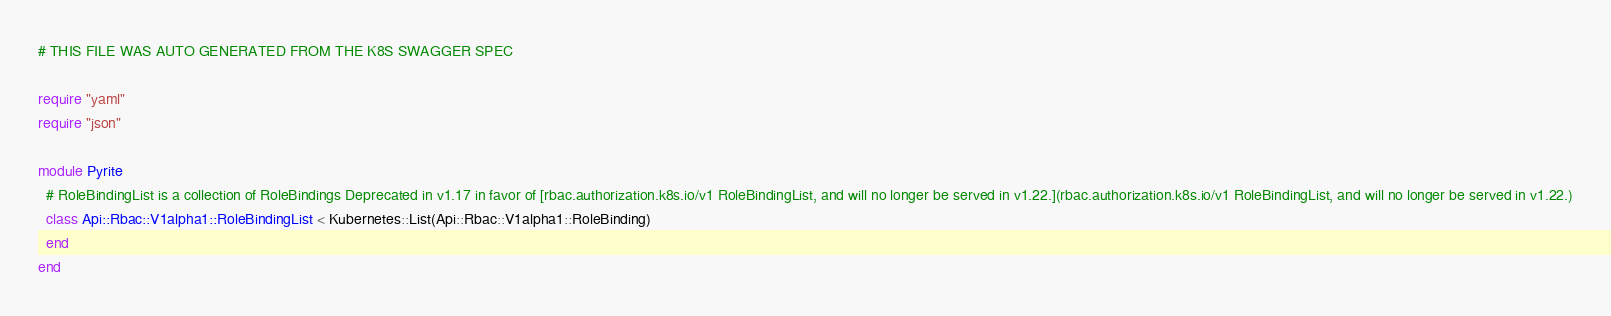<code> <loc_0><loc_0><loc_500><loc_500><_Crystal_># THIS FILE WAS AUTO GENERATED FROM THE K8S SWAGGER SPEC

require "yaml"
require "json"

module Pyrite
  # RoleBindingList is a collection of RoleBindings Deprecated in v1.17 in favor of [rbac.authorization.k8s.io/v1 RoleBindingList, and will no longer be served in v1.22.](rbac.authorization.k8s.io/v1 RoleBindingList, and will no longer be served in v1.22.)
  class Api::Rbac::V1alpha1::RoleBindingList < Kubernetes::List(Api::Rbac::V1alpha1::RoleBinding)
  end
end
</code> 